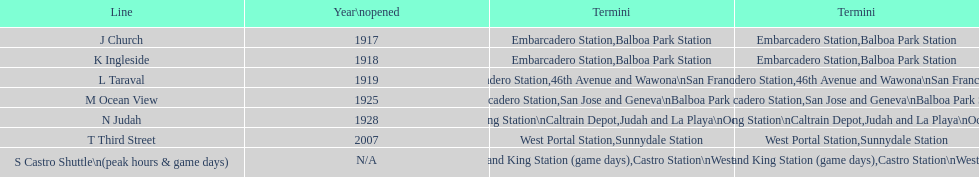On gaming days, which queue do you prefer to use? S Castro Shuttle. 